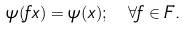Convert formula to latex. <formula><loc_0><loc_0><loc_500><loc_500>\psi ( f x ) = \psi ( x ) ; \ \forall f \in F .</formula> 